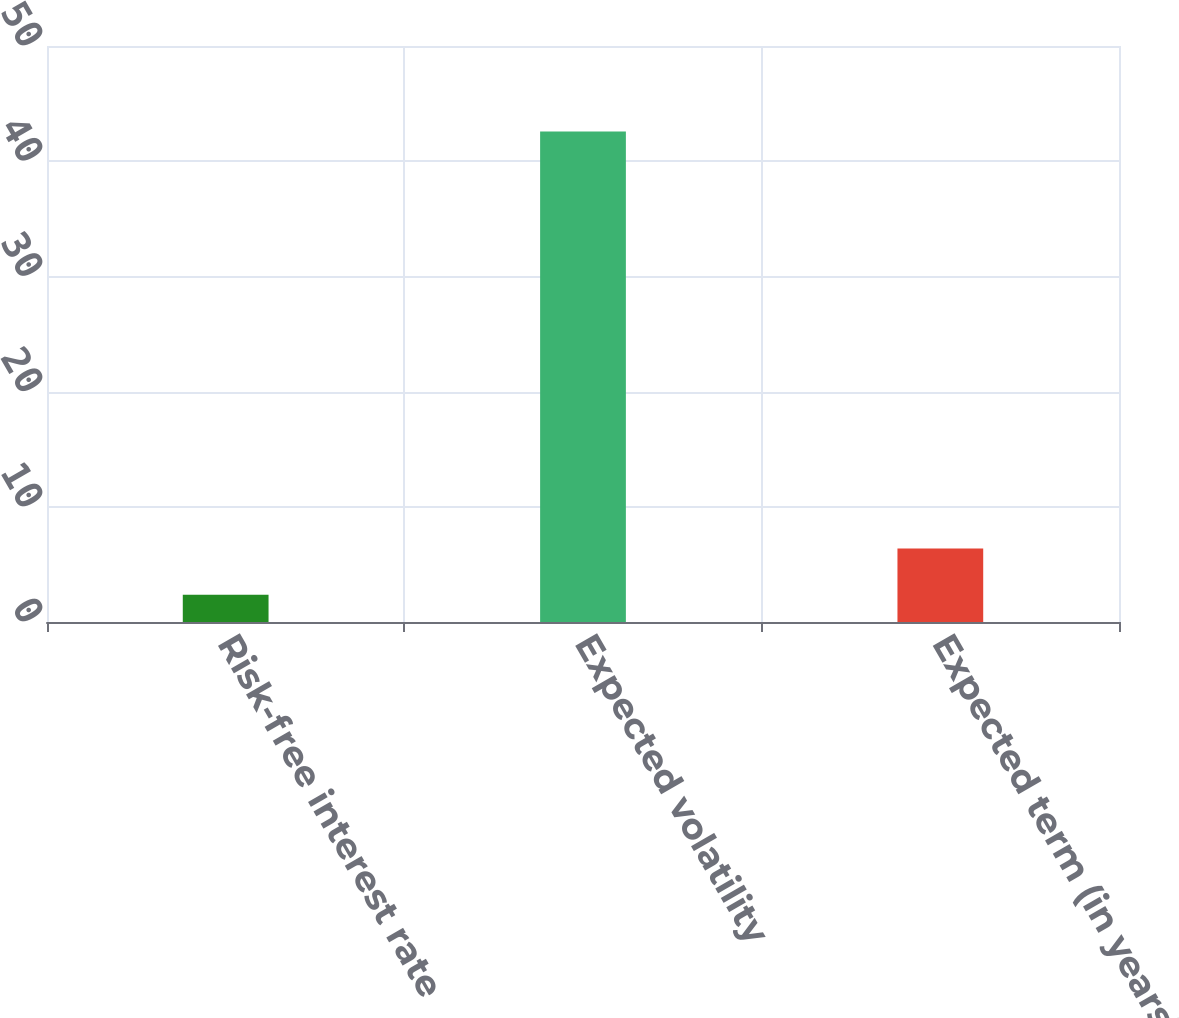Convert chart to OTSL. <chart><loc_0><loc_0><loc_500><loc_500><bar_chart><fcel>Risk-free interest rate<fcel>Expected volatility<fcel>Expected term (in years)<nl><fcel>2.36<fcel>42.57<fcel>6.38<nl></chart> 